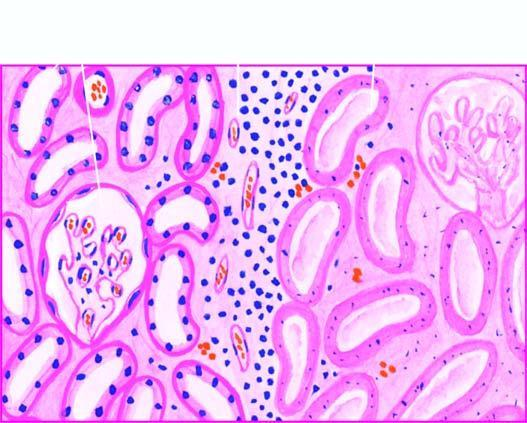what show granular debris?
Answer the question using a single word or phrase. Nuclei 